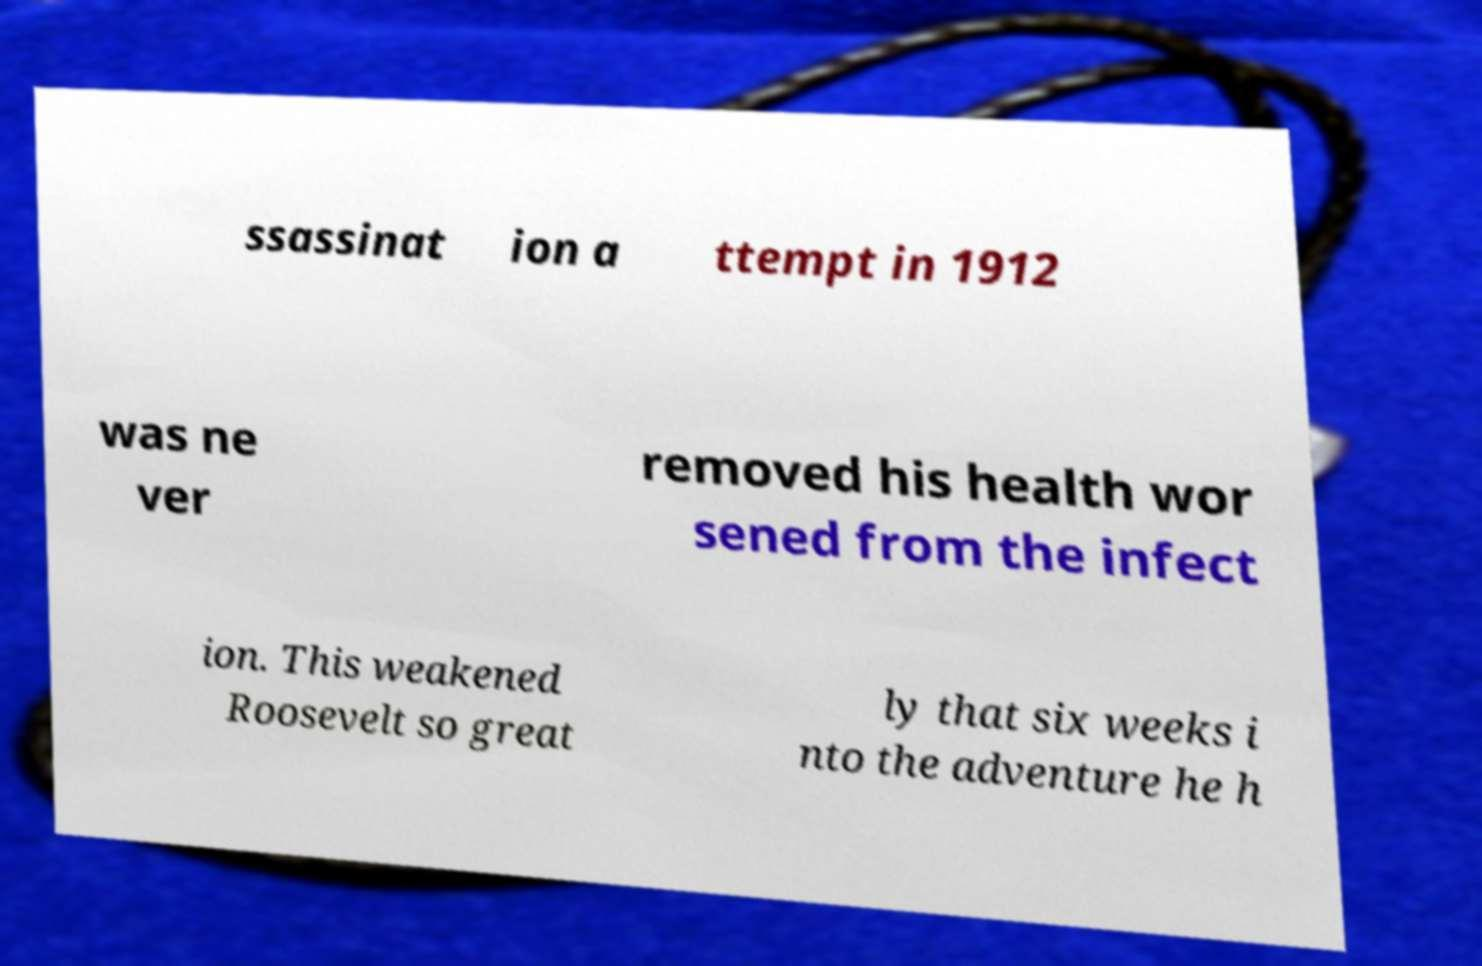What messages or text are displayed in this image? I need them in a readable, typed format. ssassinat ion a ttempt in 1912 was ne ver removed his health wor sened from the infect ion. This weakened Roosevelt so great ly that six weeks i nto the adventure he h 